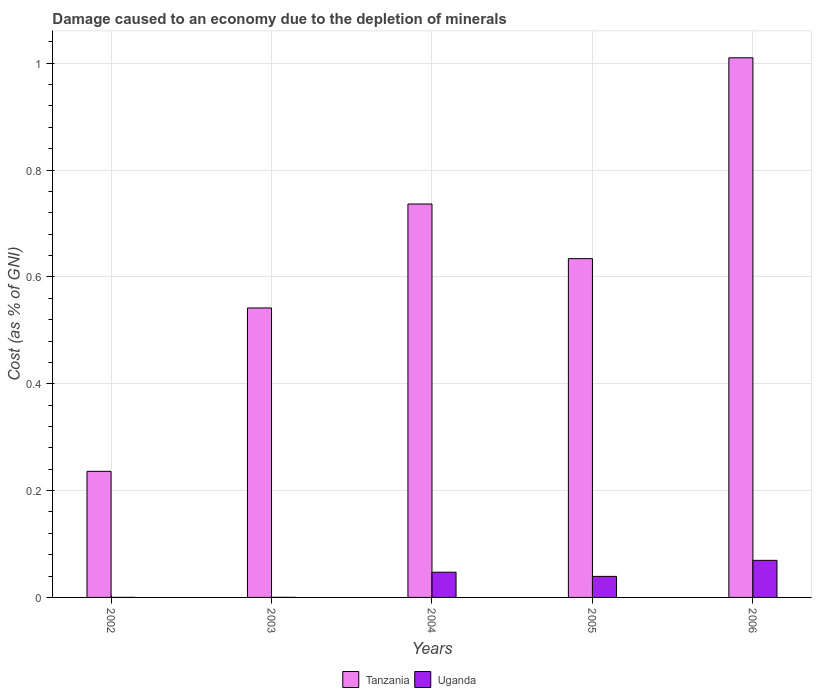How many different coloured bars are there?
Keep it short and to the point. 2. How many bars are there on the 3rd tick from the right?
Make the answer very short. 2. In how many cases, is the number of bars for a given year not equal to the number of legend labels?
Provide a succinct answer. 0. What is the cost of damage caused due to the depletion of minerals in Uganda in 2003?
Ensure brevity in your answer.  0. Across all years, what is the maximum cost of damage caused due to the depletion of minerals in Uganda?
Provide a short and direct response. 0.07. Across all years, what is the minimum cost of damage caused due to the depletion of minerals in Tanzania?
Your response must be concise. 0.24. In which year was the cost of damage caused due to the depletion of minerals in Tanzania maximum?
Keep it short and to the point. 2006. What is the total cost of damage caused due to the depletion of minerals in Tanzania in the graph?
Your answer should be compact. 3.16. What is the difference between the cost of damage caused due to the depletion of minerals in Tanzania in 2002 and that in 2004?
Offer a terse response. -0.5. What is the difference between the cost of damage caused due to the depletion of minerals in Uganda in 2005 and the cost of damage caused due to the depletion of minerals in Tanzania in 2004?
Make the answer very short. -0.7. What is the average cost of damage caused due to the depletion of minerals in Uganda per year?
Your answer should be very brief. 0.03. In the year 2002, what is the difference between the cost of damage caused due to the depletion of minerals in Uganda and cost of damage caused due to the depletion of minerals in Tanzania?
Make the answer very short. -0.24. In how many years, is the cost of damage caused due to the depletion of minerals in Tanzania greater than 0.36 %?
Your answer should be compact. 4. What is the ratio of the cost of damage caused due to the depletion of minerals in Tanzania in 2002 to that in 2005?
Keep it short and to the point. 0.37. What is the difference between the highest and the second highest cost of damage caused due to the depletion of minerals in Uganda?
Provide a short and direct response. 0.02. What is the difference between the highest and the lowest cost of damage caused due to the depletion of minerals in Tanzania?
Keep it short and to the point. 0.77. In how many years, is the cost of damage caused due to the depletion of minerals in Uganda greater than the average cost of damage caused due to the depletion of minerals in Uganda taken over all years?
Provide a short and direct response. 3. Is the sum of the cost of damage caused due to the depletion of minerals in Uganda in 2003 and 2006 greater than the maximum cost of damage caused due to the depletion of minerals in Tanzania across all years?
Keep it short and to the point. No. What does the 2nd bar from the left in 2004 represents?
Your answer should be very brief. Uganda. What does the 2nd bar from the right in 2002 represents?
Make the answer very short. Tanzania. Are all the bars in the graph horizontal?
Ensure brevity in your answer.  No. How many years are there in the graph?
Your response must be concise. 5. What is the difference between two consecutive major ticks on the Y-axis?
Keep it short and to the point. 0.2. Are the values on the major ticks of Y-axis written in scientific E-notation?
Your answer should be very brief. No. Does the graph contain grids?
Ensure brevity in your answer.  Yes. Where does the legend appear in the graph?
Provide a short and direct response. Bottom center. How many legend labels are there?
Your response must be concise. 2. What is the title of the graph?
Provide a succinct answer. Damage caused to an economy due to the depletion of minerals. Does "Namibia" appear as one of the legend labels in the graph?
Your response must be concise. No. What is the label or title of the Y-axis?
Ensure brevity in your answer.  Cost (as % of GNI). What is the Cost (as % of GNI) of Tanzania in 2002?
Ensure brevity in your answer.  0.24. What is the Cost (as % of GNI) in Uganda in 2002?
Provide a short and direct response. 7.34531955536899e-5. What is the Cost (as % of GNI) of Tanzania in 2003?
Offer a terse response. 0.54. What is the Cost (as % of GNI) in Uganda in 2003?
Make the answer very short. 0. What is the Cost (as % of GNI) of Tanzania in 2004?
Your answer should be very brief. 0.74. What is the Cost (as % of GNI) in Uganda in 2004?
Your answer should be very brief. 0.05. What is the Cost (as % of GNI) in Tanzania in 2005?
Provide a succinct answer. 0.63. What is the Cost (as % of GNI) of Uganda in 2005?
Give a very brief answer. 0.04. What is the Cost (as % of GNI) in Tanzania in 2006?
Make the answer very short. 1.01. What is the Cost (as % of GNI) of Uganda in 2006?
Give a very brief answer. 0.07. Across all years, what is the maximum Cost (as % of GNI) of Tanzania?
Give a very brief answer. 1.01. Across all years, what is the maximum Cost (as % of GNI) in Uganda?
Your answer should be compact. 0.07. Across all years, what is the minimum Cost (as % of GNI) in Tanzania?
Make the answer very short. 0.24. Across all years, what is the minimum Cost (as % of GNI) of Uganda?
Make the answer very short. 7.34531955536899e-5. What is the total Cost (as % of GNI) of Tanzania in the graph?
Provide a succinct answer. 3.16. What is the total Cost (as % of GNI) in Uganda in the graph?
Offer a very short reply. 0.16. What is the difference between the Cost (as % of GNI) of Tanzania in 2002 and that in 2003?
Provide a short and direct response. -0.31. What is the difference between the Cost (as % of GNI) in Uganda in 2002 and that in 2003?
Offer a very short reply. -0. What is the difference between the Cost (as % of GNI) of Tanzania in 2002 and that in 2004?
Provide a succinct answer. -0.5. What is the difference between the Cost (as % of GNI) of Uganda in 2002 and that in 2004?
Give a very brief answer. -0.05. What is the difference between the Cost (as % of GNI) of Tanzania in 2002 and that in 2005?
Make the answer very short. -0.4. What is the difference between the Cost (as % of GNI) in Uganda in 2002 and that in 2005?
Provide a short and direct response. -0.04. What is the difference between the Cost (as % of GNI) of Tanzania in 2002 and that in 2006?
Make the answer very short. -0.77. What is the difference between the Cost (as % of GNI) of Uganda in 2002 and that in 2006?
Provide a succinct answer. -0.07. What is the difference between the Cost (as % of GNI) in Tanzania in 2003 and that in 2004?
Give a very brief answer. -0.19. What is the difference between the Cost (as % of GNI) in Uganda in 2003 and that in 2004?
Give a very brief answer. -0.05. What is the difference between the Cost (as % of GNI) in Tanzania in 2003 and that in 2005?
Provide a succinct answer. -0.09. What is the difference between the Cost (as % of GNI) in Uganda in 2003 and that in 2005?
Give a very brief answer. -0.04. What is the difference between the Cost (as % of GNI) of Tanzania in 2003 and that in 2006?
Ensure brevity in your answer.  -0.47. What is the difference between the Cost (as % of GNI) in Uganda in 2003 and that in 2006?
Give a very brief answer. -0.07. What is the difference between the Cost (as % of GNI) in Tanzania in 2004 and that in 2005?
Make the answer very short. 0.1. What is the difference between the Cost (as % of GNI) of Uganda in 2004 and that in 2005?
Provide a succinct answer. 0.01. What is the difference between the Cost (as % of GNI) of Tanzania in 2004 and that in 2006?
Offer a very short reply. -0.27. What is the difference between the Cost (as % of GNI) in Uganda in 2004 and that in 2006?
Your answer should be very brief. -0.02. What is the difference between the Cost (as % of GNI) in Tanzania in 2005 and that in 2006?
Your answer should be compact. -0.38. What is the difference between the Cost (as % of GNI) in Uganda in 2005 and that in 2006?
Ensure brevity in your answer.  -0.03. What is the difference between the Cost (as % of GNI) in Tanzania in 2002 and the Cost (as % of GNI) in Uganda in 2003?
Give a very brief answer. 0.24. What is the difference between the Cost (as % of GNI) of Tanzania in 2002 and the Cost (as % of GNI) of Uganda in 2004?
Make the answer very short. 0.19. What is the difference between the Cost (as % of GNI) in Tanzania in 2002 and the Cost (as % of GNI) in Uganda in 2005?
Give a very brief answer. 0.2. What is the difference between the Cost (as % of GNI) in Tanzania in 2002 and the Cost (as % of GNI) in Uganda in 2006?
Provide a short and direct response. 0.17. What is the difference between the Cost (as % of GNI) in Tanzania in 2003 and the Cost (as % of GNI) in Uganda in 2004?
Keep it short and to the point. 0.49. What is the difference between the Cost (as % of GNI) of Tanzania in 2003 and the Cost (as % of GNI) of Uganda in 2005?
Your answer should be compact. 0.5. What is the difference between the Cost (as % of GNI) of Tanzania in 2003 and the Cost (as % of GNI) of Uganda in 2006?
Provide a succinct answer. 0.47. What is the difference between the Cost (as % of GNI) of Tanzania in 2004 and the Cost (as % of GNI) of Uganda in 2005?
Provide a short and direct response. 0.7. What is the difference between the Cost (as % of GNI) in Tanzania in 2004 and the Cost (as % of GNI) in Uganda in 2006?
Provide a short and direct response. 0.67. What is the difference between the Cost (as % of GNI) in Tanzania in 2005 and the Cost (as % of GNI) in Uganda in 2006?
Give a very brief answer. 0.56. What is the average Cost (as % of GNI) of Tanzania per year?
Your response must be concise. 0.63. What is the average Cost (as % of GNI) of Uganda per year?
Keep it short and to the point. 0.03. In the year 2002, what is the difference between the Cost (as % of GNI) in Tanzania and Cost (as % of GNI) in Uganda?
Offer a terse response. 0.24. In the year 2003, what is the difference between the Cost (as % of GNI) in Tanzania and Cost (as % of GNI) in Uganda?
Keep it short and to the point. 0.54. In the year 2004, what is the difference between the Cost (as % of GNI) of Tanzania and Cost (as % of GNI) of Uganda?
Ensure brevity in your answer.  0.69. In the year 2005, what is the difference between the Cost (as % of GNI) in Tanzania and Cost (as % of GNI) in Uganda?
Offer a terse response. 0.59. In the year 2006, what is the difference between the Cost (as % of GNI) of Tanzania and Cost (as % of GNI) of Uganda?
Provide a succinct answer. 0.94. What is the ratio of the Cost (as % of GNI) of Tanzania in 2002 to that in 2003?
Offer a very short reply. 0.44. What is the ratio of the Cost (as % of GNI) of Uganda in 2002 to that in 2003?
Give a very brief answer. 0.47. What is the ratio of the Cost (as % of GNI) in Tanzania in 2002 to that in 2004?
Offer a very short reply. 0.32. What is the ratio of the Cost (as % of GNI) in Uganda in 2002 to that in 2004?
Keep it short and to the point. 0. What is the ratio of the Cost (as % of GNI) in Tanzania in 2002 to that in 2005?
Provide a succinct answer. 0.37. What is the ratio of the Cost (as % of GNI) of Uganda in 2002 to that in 2005?
Give a very brief answer. 0. What is the ratio of the Cost (as % of GNI) of Tanzania in 2002 to that in 2006?
Make the answer very short. 0.23. What is the ratio of the Cost (as % of GNI) of Uganda in 2002 to that in 2006?
Provide a succinct answer. 0. What is the ratio of the Cost (as % of GNI) in Tanzania in 2003 to that in 2004?
Offer a terse response. 0.74. What is the ratio of the Cost (as % of GNI) of Uganda in 2003 to that in 2004?
Offer a very short reply. 0. What is the ratio of the Cost (as % of GNI) in Tanzania in 2003 to that in 2005?
Your response must be concise. 0.85. What is the ratio of the Cost (as % of GNI) in Uganda in 2003 to that in 2005?
Provide a short and direct response. 0. What is the ratio of the Cost (as % of GNI) in Tanzania in 2003 to that in 2006?
Offer a terse response. 0.54. What is the ratio of the Cost (as % of GNI) of Uganda in 2003 to that in 2006?
Keep it short and to the point. 0. What is the ratio of the Cost (as % of GNI) of Tanzania in 2004 to that in 2005?
Offer a very short reply. 1.16. What is the ratio of the Cost (as % of GNI) of Uganda in 2004 to that in 2005?
Provide a short and direct response. 1.2. What is the ratio of the Cost (as % of GNI) in Tanzania in 2004 to that in 2006?
Ensure brevity in your answer.  0.73. What is the ratio of the Cost (as % of GNI) in Uganda in 2004 to that in 2006?
Ensure brevity in your answer.  0.68. What is the ratio of the Cost (as % of GNI) in Tanzania in 2005 to that in 2006?
Ensure brevity in your answer.  0.63. What is the ratio of the Cost (as % of GNI) in Uganda in 2005 to that in 2006?
Provide a succinct answer. 0.57. What is the difference between the highest and the second highest Cost (as % of GNI) in Tanzania?
Your answer should be very brief. 0.27. What is the difference between the highest and the second highest Cost (as % of GNI) in Uganda?
Provide a succinct answer. 0.02. What is the difference between the highest and the lowest Cost (as % of GNI) in Tanzania?
Ensure brevity in your answer.  0.77. What is the difference between the highest and the lowest Cost (as % of GNI) in Uganda?
Provide a short and direct response. 0.07. 